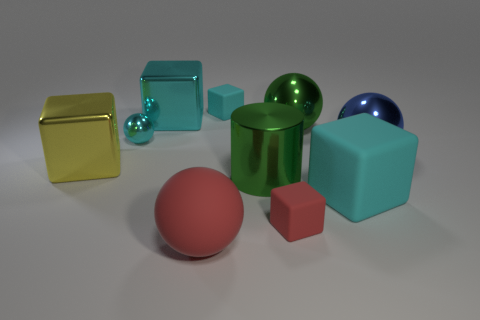Subtract all cyan cubes. How many were subtracted if there are1cyan cubes left? 2 Subtract all blue balls. How many balls are left? 3 Subtract 3 balls. How many balls are left? 1 Subtract all purple cylinders. How many cyan cubes are left? 3 Subtract all small matte objects. Subtract all green things. How many objects are left? 6 Add 1 large red balls. How many large red balls are left? 2 Add 6 small cyan blocks. How many small cyan blocks exist? 7 Subtract all cyan spheres. How many spheres are left? 3 Subtract 0 brown cylinders. How many objects are left? 10 Subtract all cylinders. How many objects are left? 9 